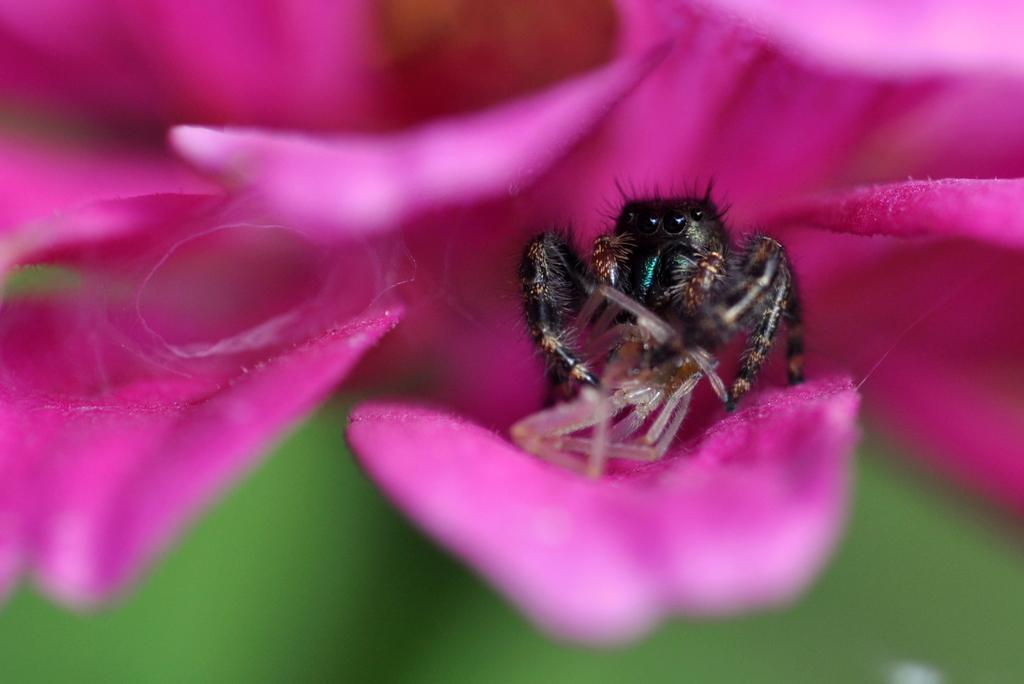What is present on the flower petal in the image? There is an insect on a flower petal in the image. What can be observed about the background of the image? The background of the image is blurred. What type of voice can be heard coming from the insect in the image? Insects do not have voices, so there is no voice present in the image. 